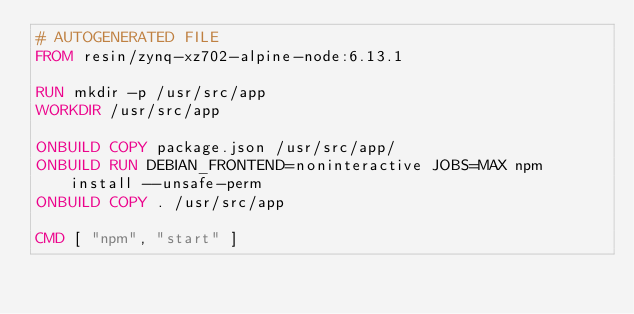<code> <loc_0><loc_0><loc_500><loc_500><_Dockerfile_># AUTOGENERATED FILE
FROM resin/zynq-xz702-alpine-node:6.13.1

RUN mkdir -p /usr/src/app
WORKDIR /usr/src/app

ONBUILD COPY package.json /usr/src/app/
ONBUILD RUN DEBIAN_FRONTEND=noninteractive JOBS=MAX npm install --unsafe-perm
ONBUILD COPY . /usr/src/app

CMD [ "npm", "start" ]
</code> 